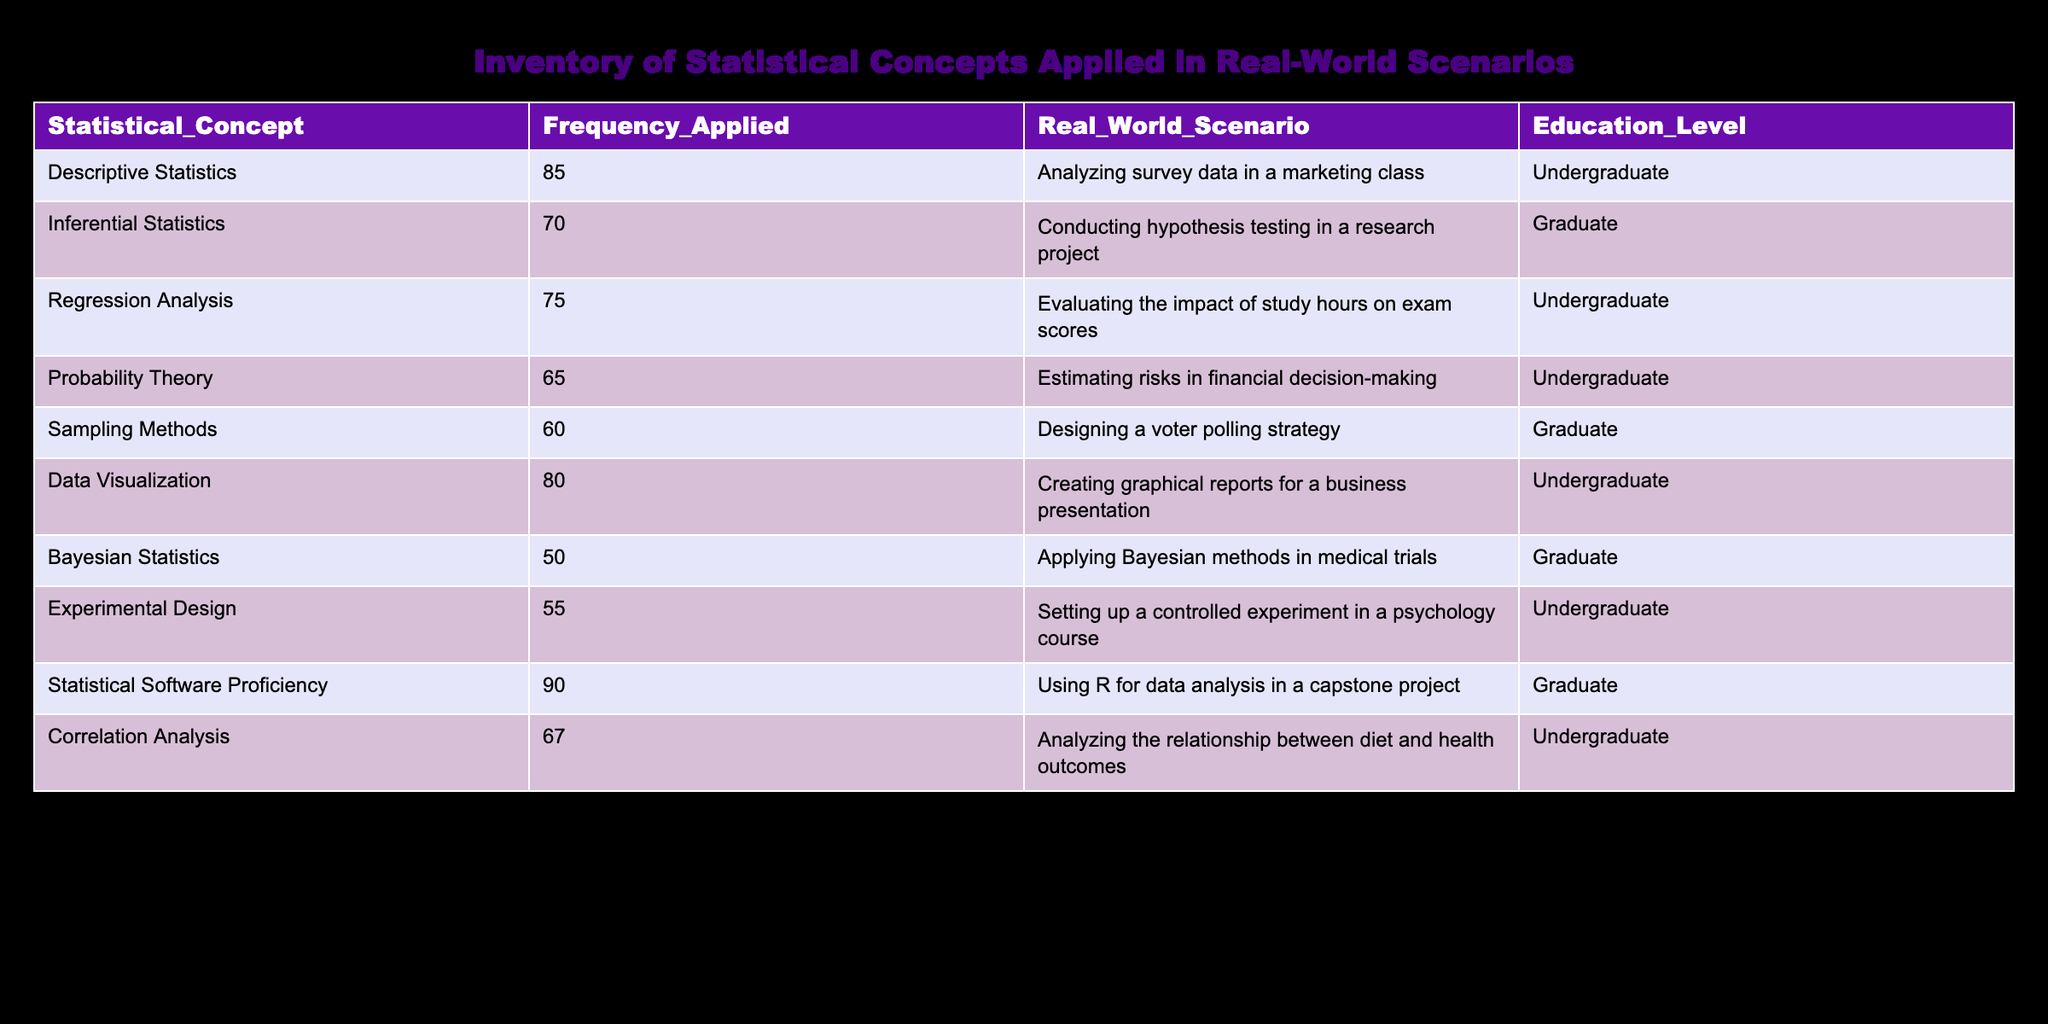What statistical concept has the highest frequency of application by undergraduate students? The table shows that "Statistical Software Proficiency" has the highest frequency applied value of 90 among undergraduate students.
Answer: 90 What is the frequency of Bayesian Statistics applied in medical trials? The table indicates that "Bayesian Statistics" has a frequency applied of 50 in medical trials.
Answer: 50 Is the frequency of applying Regression Analysis higher than Inferential Statistics for undergraduate students? The frequency for Regression Analysis is 75 and for Inferential Statistics (applicable only to graduate students) is 70. Since Regression Analysis applies to undergraduates, the answer is yes because it's 75 > 70.
Answer: Yes What is the average frequency of applied statistical concepts in the table? To find the average, sum all frequencies (85 + 70 + 75 + 65 + 60 + 80 + 50 + 55 + 90 + 67 =  757) and divide by the number of concepts (10): 757 / 10 = 75.7.
Answer: 75.7 Are undergraduate students more likely to apply Descriptive Statistics or Probability Theory? Descriptive Statistics has a frequency of 85, while Probability Theory has a frequency of 65. Thus, undergraduate students are more likely to apply Descriptive Statistics.
Answer: Yes What is the difference between the frequencies of Data Visualization and Correlation Analysis? The frequency for Data Visualization is 80, and for Correlation Analysis is 67. The difference is 80 - 67 = 13.
Answer: 13 Are sampling methods applied more frequently by graduate students than Bayesian Statistics? The frequency for Sampling Methods is 60, while for Bayesian Statistics it is 50. Since 60 is higher than 50, the answer is yes.
Answer: Yes What are the top two statistical concepts applied in real-world scenarios by undergraduate students? By looking at the frequencies, the top two concepts for undergraduates are "Statistical Software Proficiency" (90) and "Descriptive Statistics" (85).
Answer: Statistical Software Proficiency, Descriptive Statistics What is the total frequency of applied concepts for graduate students? The frequencies for graduate students are 70 (Inferential Statistics), 60 (Sampling Methods), 50 (Bayesian Statistics), and 90 (Statistical Software Proficiency). Adding these gives: 70 + 60 + 50 + 90 = 270.
Answer: 270 